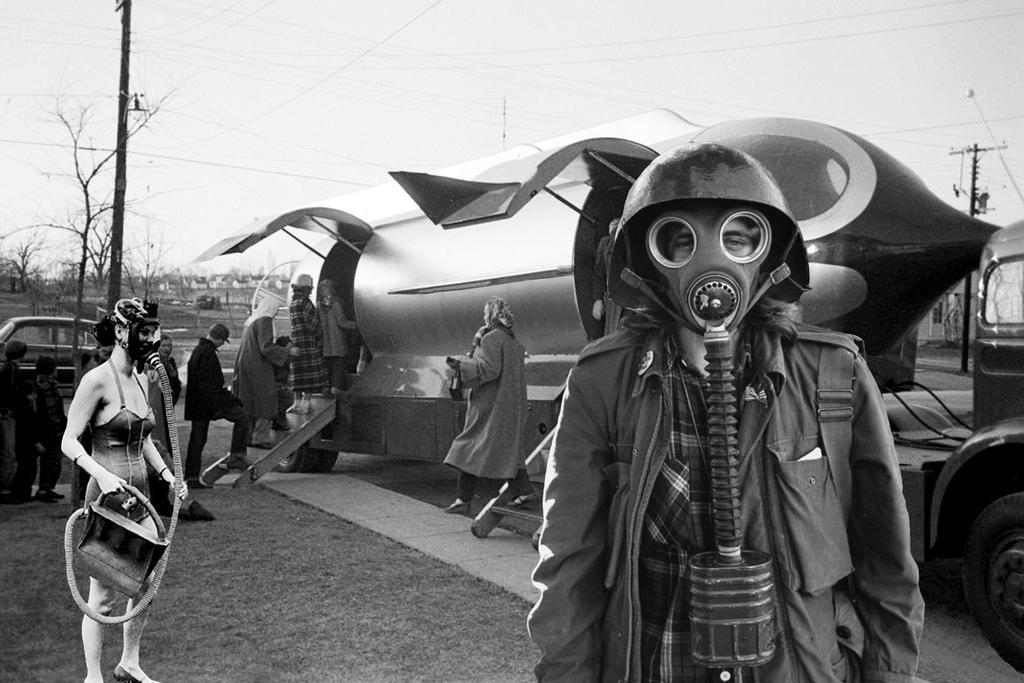In one or two sentences, can you explain what this image depicts? In this image I can see few people and few are wearing mask. I can see few vehicles,current poles,wires. The image is in black and white. 